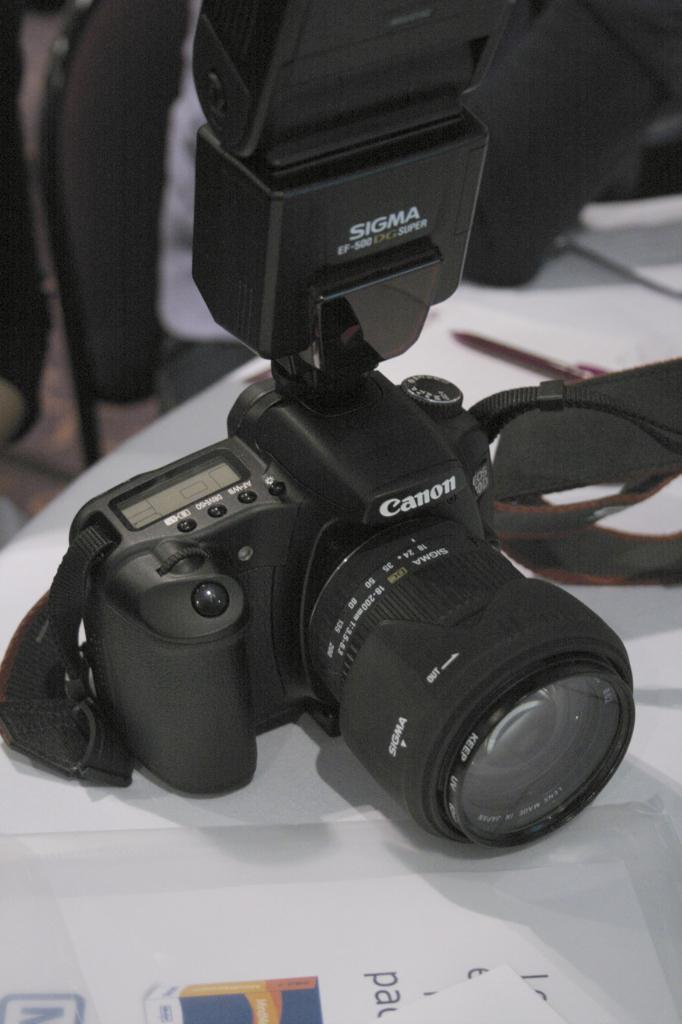What object is the main subject of the image? There is a camera in the image. Where is the camera located? The camera is placed on a table. What else can be seen in the image besides the camera? There is a white color paper in the image. How would you describe the background of the image? The background of the image is blurred. What type of tax is being discussed in the image? There is no discussion of tax in the image; it features a camera placed on a table with a white color paper and a blurred background. 